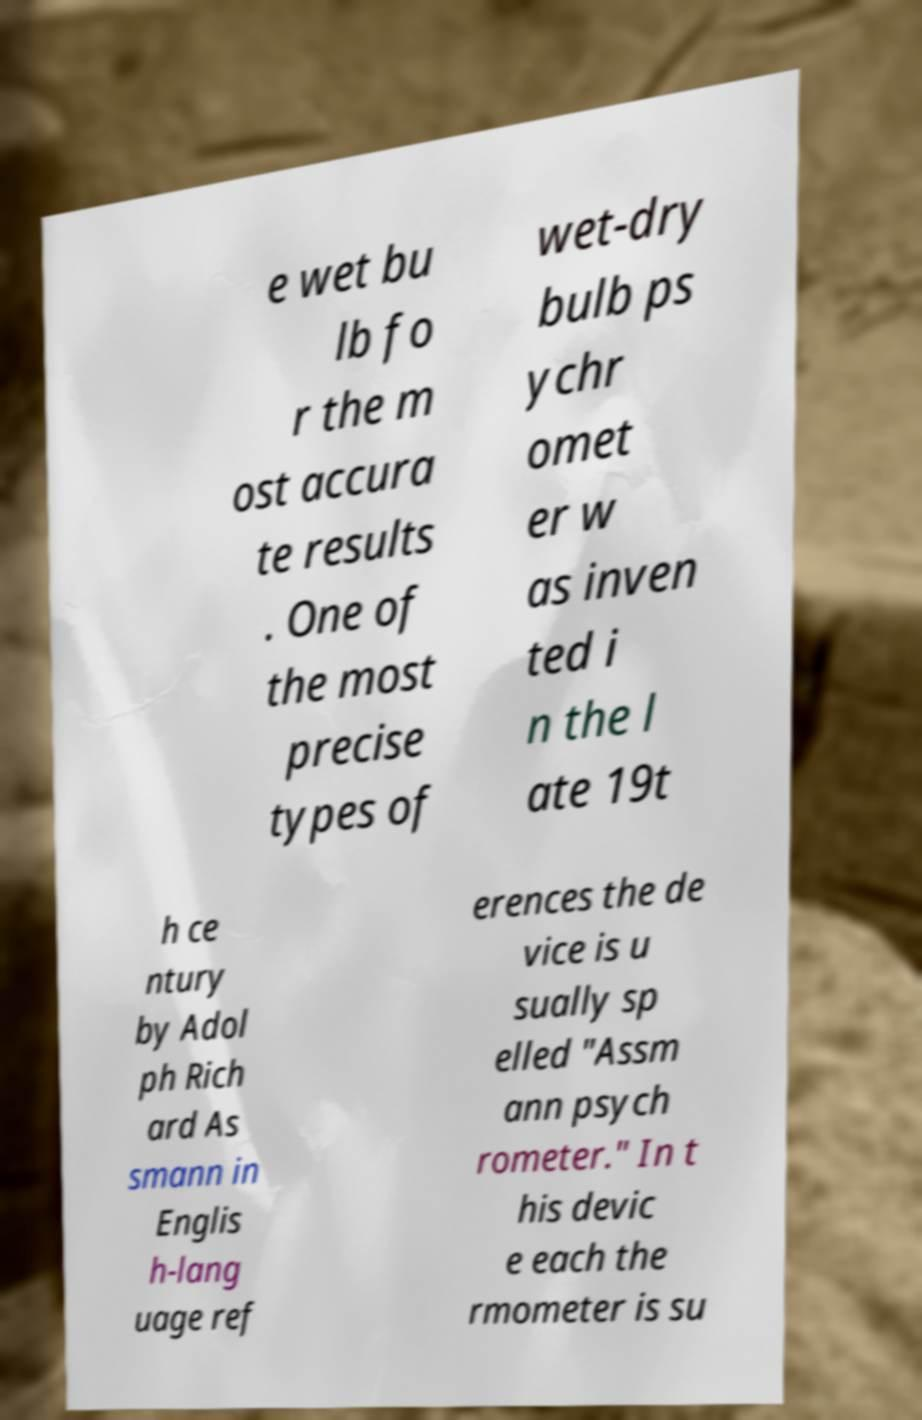There's text embedded in this image that I need extracted. Can you transcribe it verbatim? e wet bu lb fo r the m ost accura te results . One of the most precise types of wet-dry bulb ps ychr omet er w as inven ted i n the l ate 19t h ce ntury by Adol ph Rich ard As smann in Englis h-lang uage ref erences the de vice is u sually sp elled "Assm ann psych rometer." In t his devic e each the rmometer is su 